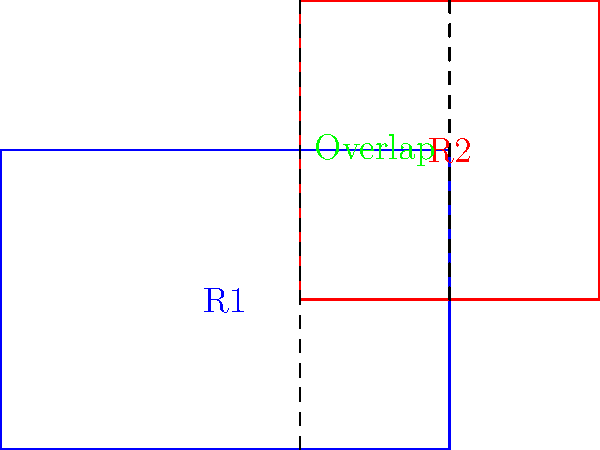In a PyQt4 application, you need to implement a 2D collision detection algorithm for moving rectangles. Given two rectangles R1 (blue) and R2 (red) as shown in the diagram, what is the most efficient way to determine if they are colliding? Provide a Python function that takes the coordinates of both rectangles as input and returns a boolean indicating whether they are colliding. To implement an efficient 2D collision detection algorithm for rectangles, we can use the Separating Axis Theorem (SAT). However, for axis-aligned rectangles, we can use a simpler method:

1. Represent each rectangle by its top-left corner coordinates (x, y) and its width and height.

2. Check for overlap on both x and y axes:
   - For x-axis: Check if the right edge of one rectangle is greater than the left edge of the other, and the left edge of the first is less than the right edge of the second.
   - For y-axis: Check if the bottom edge of one rectangle is greater than the top edge of the other, and the top edge of the first is less than the bottom edge of the second.

3. If there's overlap on both axes, the rectangles are colliding.

Here's a Python function implementing this algorithm:

```python
def check_collision(r1, r2):
    # r1 and r2 are tuples: (x, y, width, height)
    x1, y1, w1, h1 = r1
    x2, y2, w2, h2 = r2
    
    return (x1 < x2 + w2 and x1 + w1 > x2 and
            y1 < y2 + h2 and y1 + h1 > y2)
```

This function returns `True` if the rectangles are colliding, and `False` otherwise.

To use this in a PyQt4 application, you would call this function in your `paintEvent` or update loop, passing the current positions and dimensions of your rectangles.
Answer: check_collision((x1, y1, w1, h1), (x2, y2, w2, h2)) 